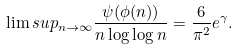Convert formula to latex. <formula><loc_0><loc_0><loc_500><loc_500>\lim s u p _ { n \to \infty } \frac { \psi ( \phi ( n ) ) } { n \log \log n } = \frac { 6 } { \pi ^ { 2 } } e ^ { \gamma } .</formula> 